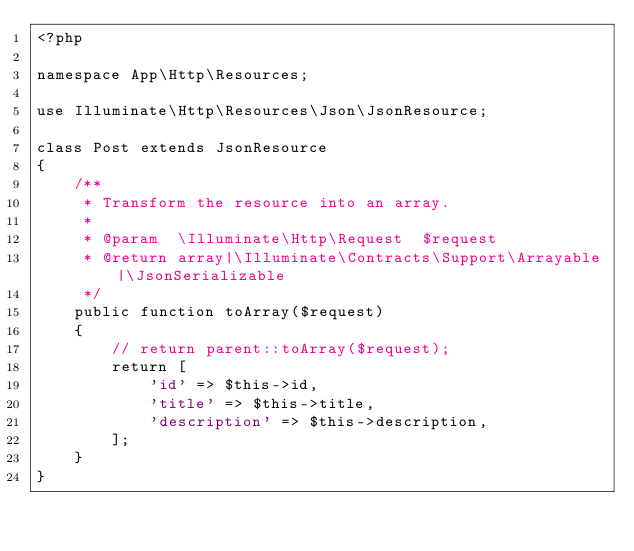<code> <loc_0><loc_0><loc_500><loc_500><_PHP_><?php

namespace App\Http\Resources;

use Illuminate\Http\Resources\Json\JsonResource;

class Post extends JsonResource
{
    /**
     * Transform the resource into an array.
     *
     * @param  \Illuminate\Http\Request  $request
     * @return array|\Illuminate\Contracts\Support\Arrayable|\JsonSerializable
     */
    public function toArray($request)
    {
        // return parent::toArray($request);
        return [
            'id' => $this->id,
            'title' => $this->title,
            'description' => $this->description,
        ];
    }
}
</code> 